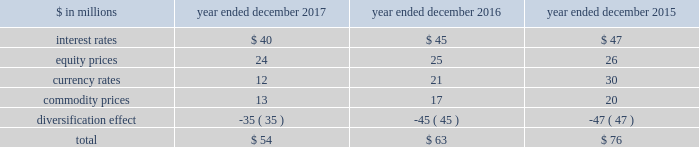The goldman sachs group , inc .
And subsidiaries management 2019s discussion and analysis the risk committee of the board and the risk governance committee ( through delegated authority from the firmwide risk committee ) approve market risk limits and sub-limits at firmwide , business and product levels , consistent with our risk appetite statement .
In addition , market risk management ( through delegated authority from the risk governance committee ) sets market risk limits and sub-limits at certain product and desk levels .
The purpose of the firmwide limits is to assist senior management in controlling our overall risk profile .
Sub-limits are set below the approved level of risk limits .
Sub-limits set the desired maximum amount of exposure that may be managed by any particular business on a day-to-day basis without additional levels of senior management approval , effectively leaving day-to-day decisions to individual desk managers and traders .
Accordingly , sub-limits are a management tool designed to ensure appropriate escalation rather than to establish maximum risk tolerance .
Sub-limits also distribute risk among various businesses in a manner that is consistent with their level of activity and client demand , taking into account the relative performance of each area .
Our market risk limits are monitored daily by market risk management , which is responsible for identifying and escalating , on a timely basis , instances where limits have been exceeded .
When a risk limit has been exceeded ( e.g. , due to positional changes or changes in market conditions , such as increased volatilities or changes in correlations ) , it is escalated to senior managers in market risk management and/or the appropriate risk committee .
Such instances are remediated by an inventory reduction and/or a temporary or permanent increase to the risk limit .
Model review and validation our var and stress testing models are regularly reviewed by market risk management and enhanced in order to incorporate changes in the composition of positions included in our market risk measures , as well as variations in market conditions .
Prior to implementing significant changes to our assumptions and/or models , model risk management performs model validations .
Significant changes to our var and stress testing models are reviewed with our chief risk officer and chief financial officer , and approved by the firmwide risk committee .
See 201cmodel risk management 201d for further information about the review and validation of these models .
Systems we have made a significant investment in technology to monitor market risk including : 2030 an independent calculation of var and stress measures ; 2030 risk measures calculated at individual position levels ; 2030 attribution of risk measures to individual risk factors of each position ; 2030 the ability to report many different views of the risk measures ( e.g. , by desk , business , product type or entity ) ; 2030 the ability to produce ad hoc analyses in a timely manner .
Metrics we analyze var at the firmwide level and a variety of more detailed levels , including by risk category , business , and region .
The tables below present average daily var and period-end var , as well as the high and low var for the period .
Diversification effect in the tables below represents the difference between total var and the sum of the vars for the four risk categories .
This effect arises because the four market risk categories are not perfectly correlated .
The table below presents average daily var by risk category. .
Our average daily var decreased to $ 54 million in 2017 from $ 63 million in 2016 , due to reductions across all risk categories , partially offset by a decrease in the diversification effect .
The overall decrease was primarily due to lower levels of volatility .
Our average daily var decreased to $ 63 million in 2016 from $ 76 million in 2015 , due to reductions across all risk categories , partially offset by a decrease in the diversification effect .
The overall decrease was primarily due to reduced exposures .
Goldman sachs 2017 form 10-k 91 .
What was the percentage change in average daily var in the interest rates risk category between 2016 and 2017? 
Computations: ((40 - 45) / 45)
Answer: -0.11111. 